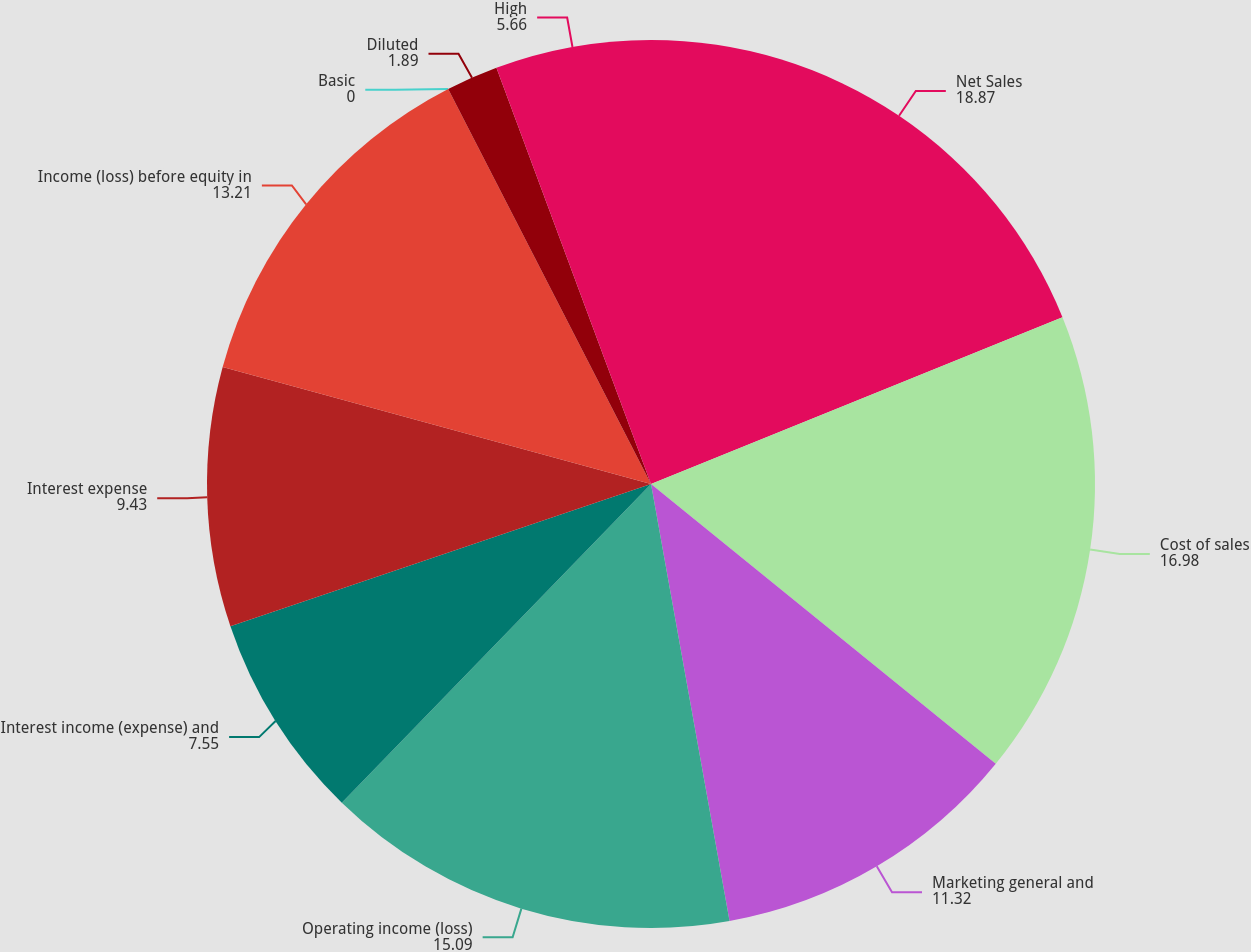Convert chart. <chart><loc_0><loc_0><loc_500><loc_500><pie_chart><fcel>Net Sales<fcel>Cost of sales<fcel>Marketing general and<fcel>Operating income (loss)<fcel>Interest income (expense) and<fcel>Interest expense<fcel>Income (loss) before equity in<fcel>Basic<fcel>Diluted<fcel>High<nl><fcel>18.87%<fcel>16.98%<fcel>11.32%<fcel>15.09%<fcel>7.55%<fcel>9.43%<fcel>13.21%<fcel>0.0%<fcel>1.89%<fcel>5.66%<nl></chart> 